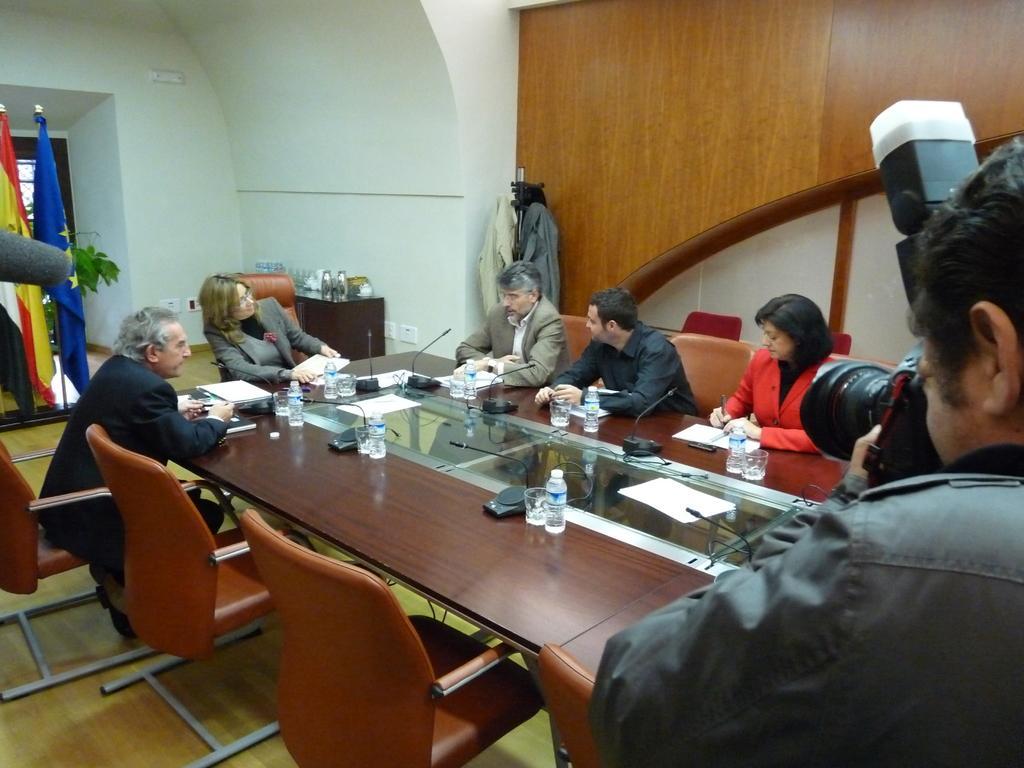Can you describe this image briefly? On the right a man is standing and taking photographs in a camera in the left there are people sitting around the table. 